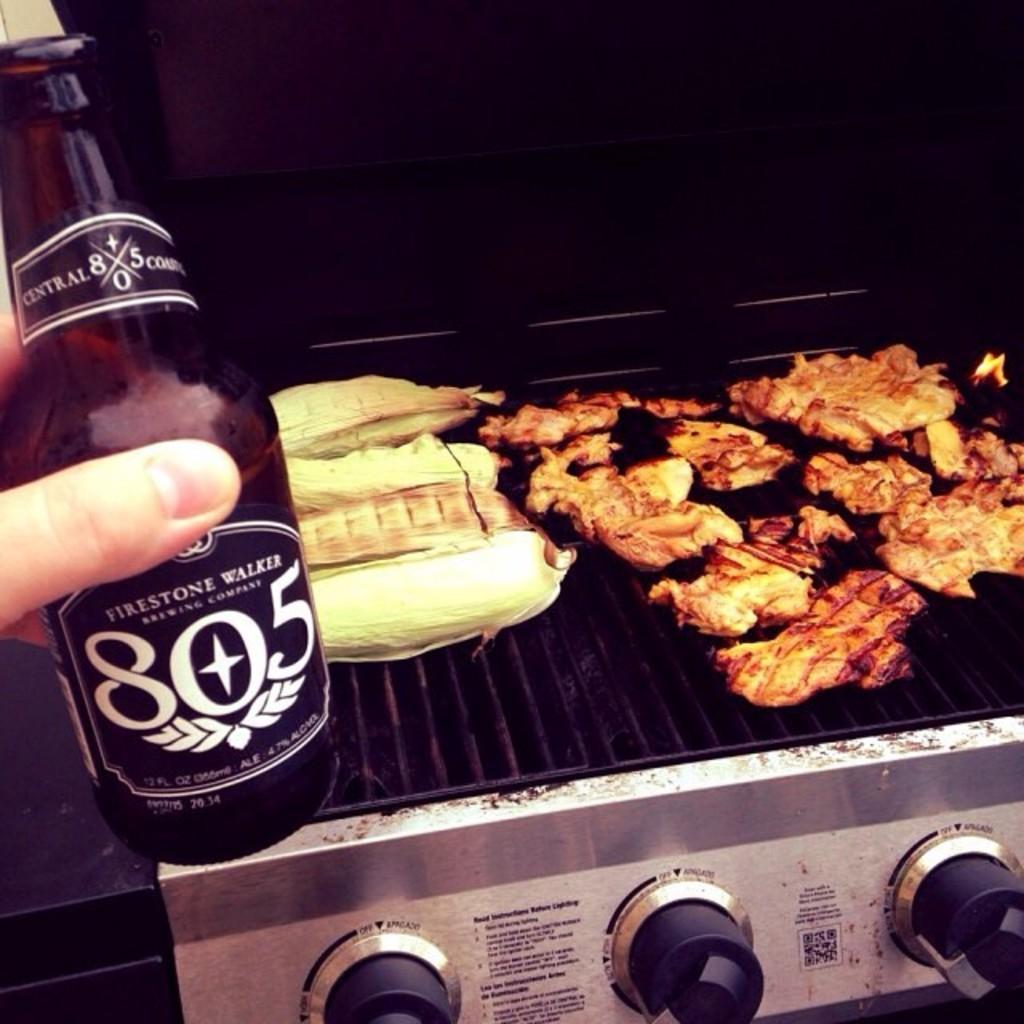What brand of beer?
Offer a terse response. Firestone walker. 